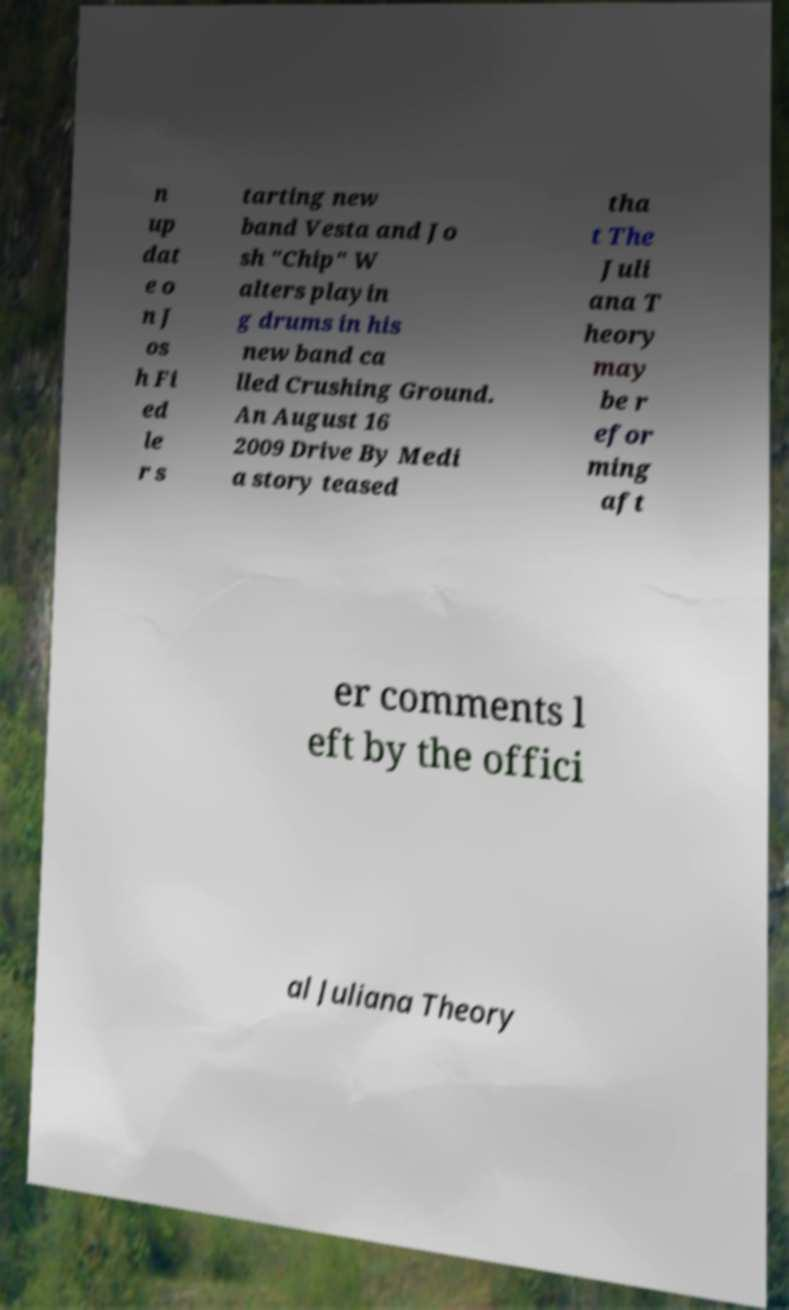For documentation purposes, I need the text within this image transcribed. Could you provide that? n up dat e o n J os h Fi ed le r s tarting new band Vesta and Jo sh "Chip" W alters playin g drums in his new band ca lled Crushing Ground. An August 16 2009 Drive By Medi a story teased tha t The Juli ana T heory may be r efor ming aft er comments l eft by the offici al Juliana Theory 